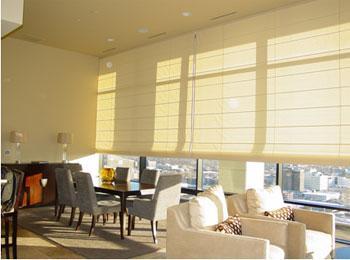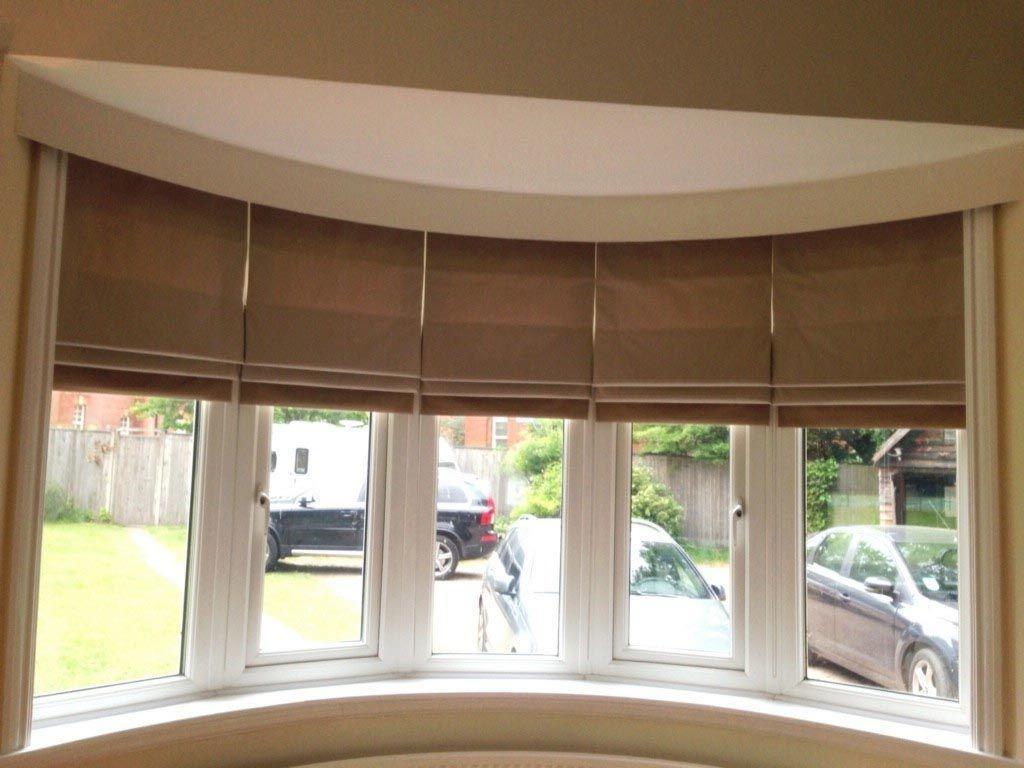The first image is the image on the left, the second image is the image on the right. Assess this claim about the two images: "The right image features windows covered by at least one dark brown shade.". Correct or not? Answer yes or no. Yes. The first image is the image on the left, the second image is the image on the right. For the images displayed, is the sentence "The left and right image contains the same number of windows." factually correct? Answer yes or no. No. 